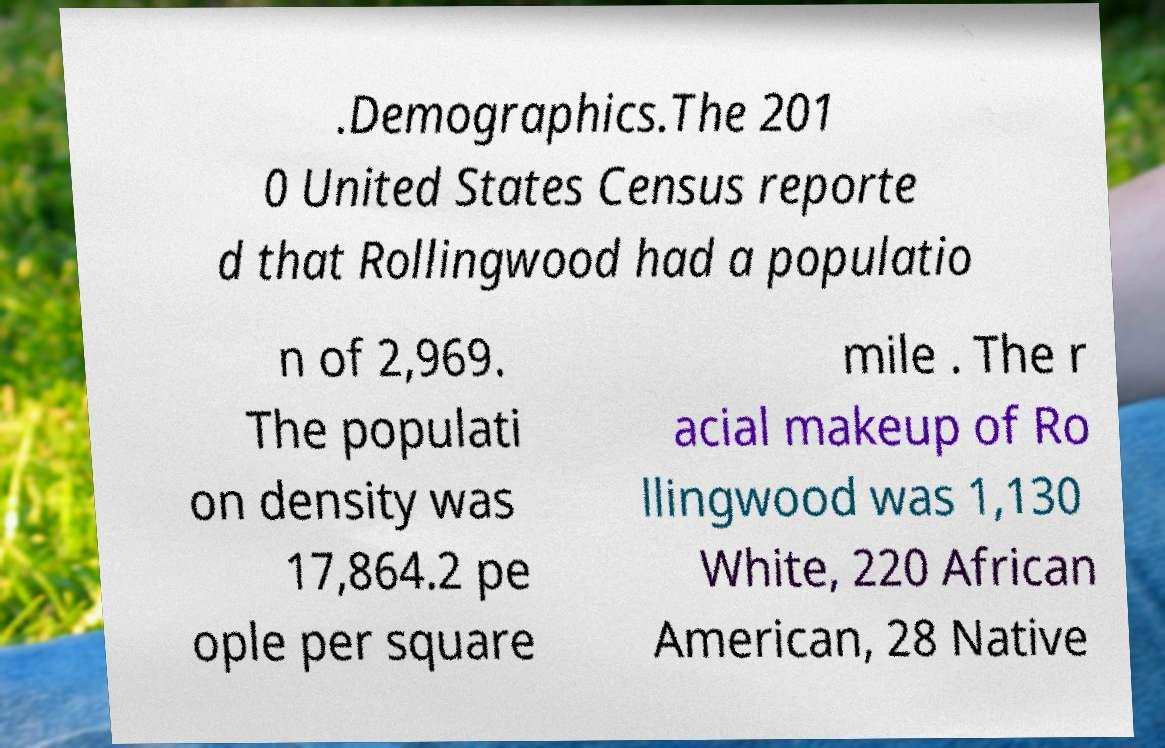Could you assist in decoding the text presented in this image and type it out clearly? .Demographics.The 201 0 United States Census reporte d that Rollingwood had a populatio n of 2,969. The populati on density was 17,864.2 pe ople per square mile . The r acial makeup of Ro llingwood was 1,130 White, 220 African American, 28 Native 